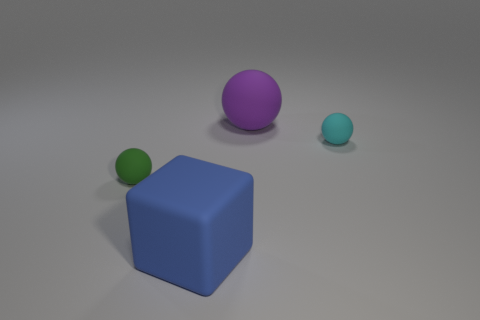The thing to the left of the large blue matte thing has what shape?
Keep it short and to the point. Sphere. Is the number of large purple things less than the number of big gray matte cylinders?
Make the answer very short. No. Is there any other thing that is the same color as the large sphere?
Your answer should be very brief. No. There is a cyan ball that is to the right of the green matte object; how big is it?
Your response must be concise. Small. Is the number of small green matte spheres greater than the number of matte balls?
Make the answer very short. No. What material is the green ball?
Ensure brevity in your answer.  Rubber. What number of other objects are there of the same material as the large block?
Offer a terse response. 3. How many spheres are there?
Your response must be concise. 3. There is a small green object that is the same shape as the purple object; what is its material?
Keep it short and to the point. Rubber. Does the thing left of the blue block have the same material as the blue block?
Provide a short and direct response. Yes. 